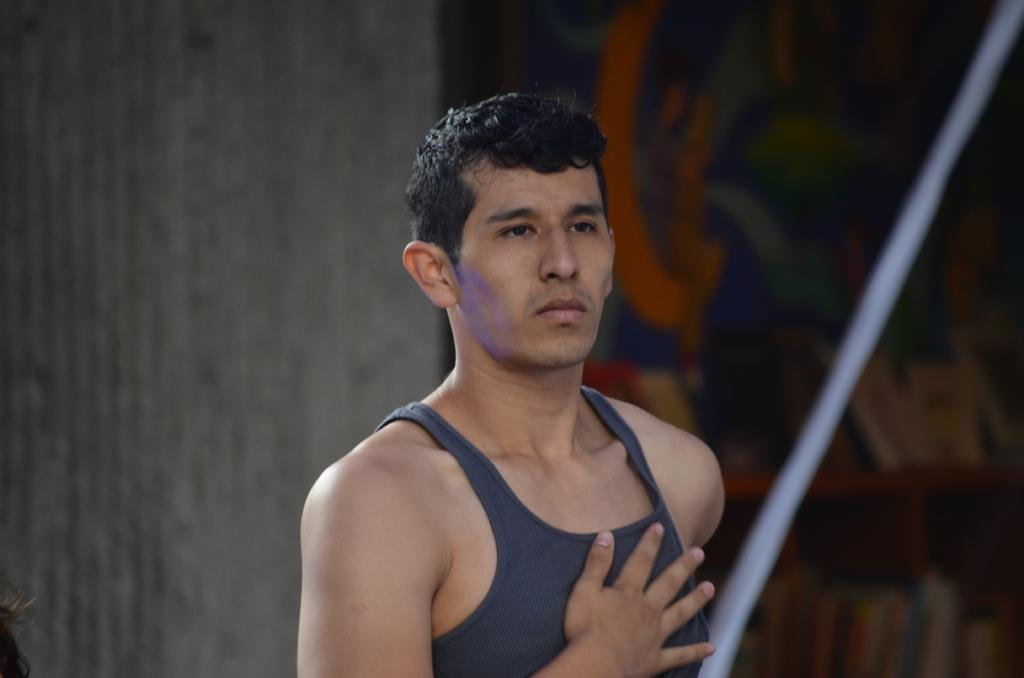What is the main subject of the image? There is a man in the image. What is the man doing with his hand in the image? The man has his hand on his chest in the image. What color is the clothing the man is wearing? The man is wearing grey-colored clothing. How many pigs are visible in the image? There are no pigs present in the image. What is the mass of the man in the image? The mass of the man cannot be determined from the image alone. 